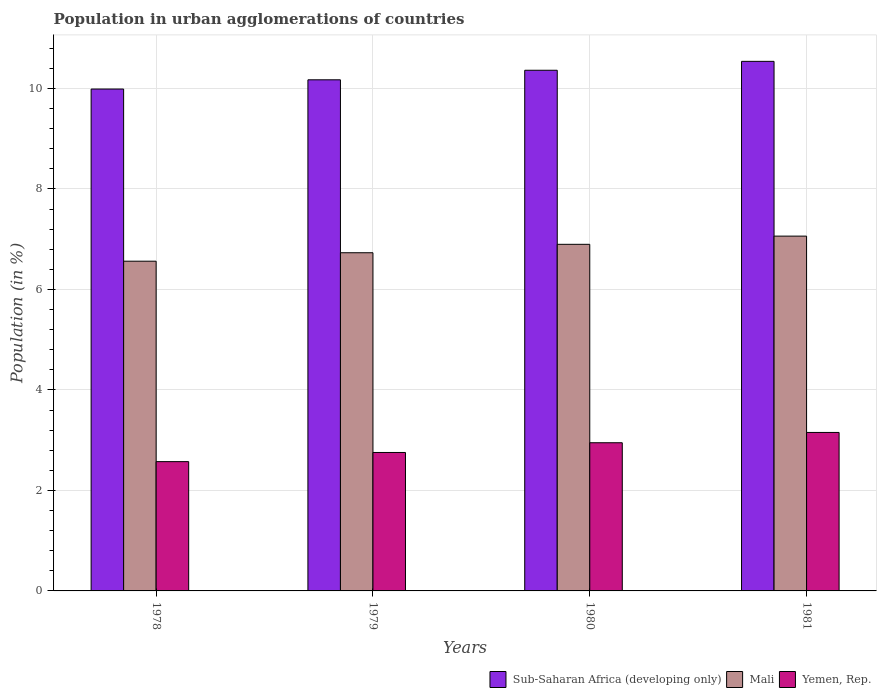How many different coloured bars are there?
Offer a terse response. 3. How many groups of bars are there?
Your response must be concise. 4. Are the number of bars per tick equal to the number of legend labels?
Provide a succinct answer. Yes. Are the number of bars on each tick of the X-axis equal?
Offer a terse response. Yes. How many bars are there on the 1st tick from the left?
Your answer should be very brief. 3. What is the label of the 3rd group of bars from the left?
Offer a very short reply. 1980. What is the percentage of population in urban agglomerations in Mali in 1981?
Keep it short and to the point. 7.06. Across all years, what is the maximum percentage of population in urban agglomerations in Yemen, Rep.?
Offer a terse response. 3.15. Across all years, what is the minimum percentage of population in urban agglomerations in Sub-Saharan Africa (developing only)?
Give a very brief answer. 9.99. In which year was the percentage of population in urban agglomerations in Yemen, Rep. maximum?
Ensure brevity in your answer.  1981. In which year was the percentage of population in urban agglomerations in Yemen, Rep. minimum?
Your response must be concise. 1978. What is the total percentage of population in urban agglomerations in Sub-Saharan Africa (developing only) in the graph?
Your answer should be compact. 41.06. What is the difference between the percentage of population in urban agglomerations in Mali in 1978 and that in 1981?
Ensure brevity in your answer.  -0.5. What is the difference between the percentage of population in urban agglomerations in Sub-Saharan Africa (developing only) in 1981 and the percentage of population in urban agglomerations in Mali in 1978?
Make the answer very short. 3.98. What is the average percentage of population in urban agglomerations in Mali per year?
Your answer should be very brief. 6.81. In the year 1979, what is the difference between the percentage of population in urban agglomerations in Yemen, Rep. and percentage of population in urban agglomerations in Sub-Saharan Africa (developing only)?
Make the answer very short. -7.42. What is the ratio of the percentage of population in urban agglomerations in Sub-Saharan Africa (developing only) in 1980 to that in 1981?
Offer a terse response. 0.98. Is the difference between the percentage of population in urban agglomerations in Yemen, Rep. in 1979 and 1980 greater than the difference between the percentage of population in urban agglomerations in Sub-Saharan Africa (developing only) in 1979 and 1980?
Your answer should be very brief. No. What is the difference between the highest and the second highest percentage of population in urban agglomerations in Sub-Saharan Africa (developing only)?
Offer a very short reply. 0.18. What is the difference between the highest and the lowest percentage of population in urban agglomerations in Sub-Saharan Africa (developing only)?
Your response must be concise. 0.55. What does the 2nd bar from the left in 1981 represents?
Your answer should be compact. Mali. What does the 3rd bar from the right in 1979 represents?
Offer a very short reply. Sub-Saharan Africa (developing only). Is it the case that in every year, the sum of the percentage of population in urban agglomerations in Mali and percentage of population in urban agglomerations in Sub-Saharan Africa (developing only) is greater than the percentage of population in urban agglomerations in Yemen, Rep.?
Your response must be concise. Yes. Are all the bars in the graph horizontal?
Ensure brevity in your answer.  No. Does the graph contain grids?
Provide a succinct answer. Yes. What is the title of the graph?
Provide a succinct answer. Population in urban agglomerations of countries. What is the Population (in %) of Sub-Saharan Africa (developing only) in 1978?
Offer a terse response. 9.99. What is the Population (in %) of Mali in 1978?
Provide a succinct answer. 6.56. What is the Population (in %) of Yemen, Rep. in 1978?
Offer a very short reply. 2.57. What is the Population (in %) in Sub-Saharan Africa (developing only) in 1979?
Your response must be concise. 10.17. What is the Population (in %) of Mali in 1979?
Provide a succinct answer. 6.73. What is the Population (in %) in Yemen, Rep. in 1979?
Make the answer very short. 2.76. What is the Population (in %) in Sub-Saharan Africa (developing only) in 1980?
Ensure brevity in your answer.  10.36. What is the Population (in %) in Mali in 1980?
Provide a succinct answer. 6.9. What is the Population (in %) in Yemen, Rep. in 1980?
Keep it short and to the point. 2.95. What is the Population (in %) of Sub-Saharan Africa (developing only) in 1981?
Your response must be concise. 10.54. What is the Population (in %) in Mali in 1981?
Provide a short and direct response. 7.06. What is the Population (in %) in Yemen, Rep. in 1981?
Provide a short and direct response. 3.15. Across all years, what is the maximum Population (in %) of Sub-Saharan Africa (developing only)?
Provide a short and direct response. 10.54. Across all years, what is the maximum Population (in %) of Mali?
Ensure brevity in your answer.  7.06. Across all years, what is the maximum Population (in %) in Yemen, Rep.?
Your response must be concise. 3.15. Across all years, what is the minimum Population (in %) in Sub-Saharan Africa (developing only)?
Offer a terse response. 9.99. Across all years, what is the minimum Population (in %) in Mali?
Give a very brief answer. 6.56. Across all years, what is the minimum Population (in %) in Yemen, Rep.?
Your answer should be compact. 2.57. What is the total Population (in %) of Sub-Saharan Africa (developing only) in the graph?
Offer a very short reply. 41.06. What is the total Population (in %) in Mali in the graph?
Offer a terse response. 27.25. What is the total Population (in %) of Yemen, Rep. in the graph?
Ensure brevity in your answer.  11.43. What is the difference between the Population (in %) of Sub-Saharan Africa (developing only) in 1978 and that in 1979?
Your answer should be compact. -0.18. What is the difference between the Population (in %) of Mali in 1978 and that in 1979?
Offer a very short reply. -0.17. What is the difference between the Population (in %) in Yemen, Rep. in 1978 and that in 1979?
Offer a very short reply. -0.18. What is the difference between the Population (in %) of Sub-Saharan Africa (developing only) in 1978 and that in 1980?
Ensure brevity in your answer.  -0.37. What is the difference between the Population (in %) of Mali in 1978 and that in 1980?
Your response must be concise. -0.34. What is the difference between the Population (in %) of Yemen, Rep. in 1978 and that in 1980?
Offer a very short reply. -0.38. What is the difference between the Population (in %) in Sub-Saharan Africa (developing only) in 1978 and that in 1981?
Give a very brief answer. -0.55. What is the difference between the Population (in %) in Mali in 1978 and that in 1981?
Offer a very short reply. -0.5. What is the difference between the Population (in %) in Yemen, Rep. in 1978 and that in 1981?
Your answer should be compact. -0.58. What is the difference between the Population (in %) of Sub-Saharan Africa (developing only) in 1979 and that in 1980?
Provide a succinct answer. -0.19. What is the difference between the Population (in %) in Mali in 1979 and that in 1980?
Provide a succinct answer. -0.17. What is the difference between the Population (in %) of Yemen, Rep. in 1979 and that in 1980?
Provide a succinct answer. -0.19. What is the difference between the Population (in %) of Sub-Saharan Africa (developing only) in 1979 and that in 1981?
Make the answer very short. -0.37. What is the difference between the Population (in %) in Mali in 1979 and that in 1981?
Keep it short and to the point. -0.33. What is the difference between the Population (in %) of Yemen, Rep. in 1979 and that in 1981?
Provide a short and direct response. -0.4. What is the difference between the Population (in %) of Sub-Saharan Africa (developing only) in 1980 and that in 1981?
Your answer should be compact. -0.18. What is the difference between the Population (in %) in Mali in 1980 and that in 1981?
Provide a short and direct response. -0.16. What is the difference between the Population (in %) in Yemen, Rep. in 1980 and that in 1981?
Offer a very short reply. -0.2. What is the difference between the Population (in %) in Sub-Saharan Africa (developing only) in 1978 and the Population (in %) in Mali in 1979?
Provide a succinct answer. 3.26. What is the difference between the Population (in %) in Sub-Saharan Africa (developing only) in 1978 and the Population (in %) in Yemen, Rep. in 1979?
Your response must be concise. 7.23. What is the difference between the Population (in %) in Mali in 1978 and the Population (in %) in Yemen, Rep. in 1979?
Your answer should be compact. 3.81. What is the difference between the Population (in %) in Sub-Saharan Africa (developing only) in 1978 and the Population (in %) in Mali in 1980?
Offer a terse response. 3.09. What is the difference between the Population (in %) in Sub-Saharan Africa (developing only) in 1978 and the Population (in %) in Yemen, Rep. in 1980?
Provide a short and direct response. 7.04. What is the difference between the Population (in %) in Mali in 1978 and the Population (in %) in Yemen, Rep. in 1980?
Ensure brevity in your answer.  3.61. What is the difference between the Population (in %) in Sub-Saharan Africa (developing only) in 1978 and the Population (in %) in Mali in 1981?
Provide a short and direct response. 2.93. What is the difference between the Population (in %) of Sub-Saharan Africa (developing only) in 1978 and the Population (in %) of Yemen, Rep. in 1981?
Make the answer very short. 6.83. What is the difference between the Population (in %) in Mali in 1978 and the Population (in %) in Yemen, Rep. in 1981?
Ensure brevity in your answer.  3.41. What is the difference between the Population (in %) in Sub-Saharan Africa (developing only) in 1979 and the Population (in %) in Mali in 1980?
Provide a short and direct response. 3.27. What is the difference between the Population (in %) in Sub-Saharan Africa (developing only) in 1979 and the Population (in %) in Yemen, Rep. in 1980?
Give a very brief answer. 7.22. What is the difference between the Population (in %) in Mali in 1979 and the Population (in %) in Yemen, Rep. in 1980?
Give a very brief answer. 3.78. What is the difference between the Population (in %) in Sub-Saharan Africa (developing only) in 1979 and the Population (in %) in Mali in 1981?
Provide a succinct answer. 3.11. What is the difference between the Population (in %) of Sub-Saharan Africa (developing only) in 1979 and the Population (in %) of Yemen, Rep. in 1981?
Offer a very short reply. 7.02. What is the difference between the Population (in %) of Mali in 1979 and the Population (in %) of Yemen, Rep. in 1981?
Provide a short and direct response. 3.58. What is the difference between the Population (in %) of Sub-Saharan Africa (developing only) in 1980 and the Population (in %) of Mali in 1981?
Offer a terse response. 3.3. What is the difference between the Population (in %) in Sub-Saharan Africa (developing only) in 1980 and the Population (in %) in Yemen, Rep. in 1981?
Provide a succinct answer. 7.21. What is the difference between the Population (in %) in Mali in 1980 and the Population (in %) in Yemen, Rep. in 1981?
Your response must be concise. 3.74. What is the average Population (in %) of Sub-Saharan Africa (developing only) per year?
Offer a terse response. 10.27. What is the average Population (in %) of Mali per year?
Your answer should be very brief. 6.81. What is the average Population (in %) of Yemen, Rep. per year?
Offer a very short reply. 2.86. In the year 1978, what is the difference between the Population (in %) of Sub-Saharan Africa (developing only) and Population (in %) of Mali?
Provide a short and direct response. 3.43. In the year 1978, what is the difference between the Population (in %) in Sub-Saharan Africa (developing only) and Population (in %) in Yemen, Rep.?
Give a very brief answer. 7.42. In the year 1978, what is the difference between the Population (in %) of Mali and Population (in %) of Yemen, Rep.?
Your answer should be compact. 3.99. In the year 1979, what is the difference between the Population (in %) of Sub-Saharan Africa (developing only) and Population (in %) of Mali?
Provide a short and direct response. 3.44. In the year 1979, what is the difference between the Population (in %) of Sub-Saharan Africa (developing only) and Population (in %) of Yemen, Rep.?
Ensure brevity in your answer.  7.42. In the year 1979, what is the difference between the Population (in %) of Mali and Population (in %) of Yemen, Rep.?
Provide a succinct answer. 3.98. In the year 1980, what is the difference between the Population (in %) of Sub-Saharan Africa (developing only) and Population (in %) of Mali?
Provide a short and direct response. 3.46. In the year 1980, what is the difference between the Population (in %) of Sub-Saharan Africa (developing only) and Population (in %) of Yemen, Rep.?
Offer a very short reply. 7.41. In the year 1980, what is the difference between the Population (in %) of Mali and Population (in %) of Yemen, Rep.?
Provide a succinct answer. 3.95. In the year 1981, what is the difference between the Population (in %) in Sub-Saharan Africa (developing only) and Population (in %) in Mali?
Provide a succinct answer. 3.48. In the year 1981, what is the difference between the Population (in %) in Sub-Saharan Africa (developing only) and Population (in %) in Yemen, Rep.?
Your answer should be very brief. 7.39. In the year 1981, what is the difference between the Population (in %) of Mali and Population (in %) of Yemen, Rep.?
Keep it short and to the point. 3.91. What is the ratio of the Population (in %) of Sub-Saharan Africa (developing only) in 1978 to that in 1979?
Give a very brief answer. 0.98. What is the ratio of the Population (in %) of Yemen, Rep. in 1978 to that in 1979?
Keep it short and to the point. 0.93. What is the ratio of the Population (in %) of Sub-Saharan Africa (developing only) in 1978 to that in 1980?
Make the answer very short. 0.96. What is the ratio of the Population (in %) in Mali in 1978 to that in 1980?
Provide a succinct answer. 0.95. What is the ratio of the Population (in %) of Yemen, Rep. in 1978 to that in 1980?
Make the answer very short. 0.87. What is the ratio of the Population (in %) in Sub-Saharan Africa (developing only) in 1978 to that in 1981?
Offer a terse response. 0.95. What is the ratio of the Population (in %) of Mali in 1978 to that in 1981?
Make the answer very short. 0.93. What is the ratio of the Population (in %) in Yemen, Rep. in 1978 to that in 1981?
Offer a terse response. 0.82. What is the ratio of the Population (in %) of Sub-Saharan Africa (developing only) in 1979 to that in 1980?
Offer a terse response. 0.98. What is the ratio of the Population (in %) in Mali in 1979 to that in 1980?
Make the answer very short. 0.98. What is the ratio of the Population (in %) of Yemen, Rep. in 1979 to that in 1980?
Provide a short and direct response. 0.93. What is the ratio of the Population (in %) of Sub-Saharan Africa (developing only) in 1979 to that in 1981?
Make the answer very short. 0.97. What is the ratio of the Population (in %) of Mali in 1979 to that in 1981?
Provide a short and direct response. 0.95. What is the ratio of the Population (in %) of Yemen, Rep. in 1979 to that in 1981?
Offer a very short reply. 0.87. What is the ratio of the Population (in %) in Sub-Saharan Africa (developing only) in 1980 to that in 1981?
Keep it short and to the point. 0.98. What is the ratio of the Population (in %) in Mali in 1980 to that in 1981?
Your response must be concise. 0.98. What is the ratio of the Population (in %) in Yemen, Rep. in 1980 to that in 1981?
Keep it short and to the point. 0.94. What is the difference between the highest and the second highest Population (in %) in Sub-Saharan Africa (developing only)?
Make the answer very short. 0.18. What is the difference between the highest and the second highest Population (in %) in Mali?
Offer a very short reply. 0.16. What is the difference between the highest and the second highest Population (in %) in Yemen, Rep.?
Offer a terse response. 0.2. What is the difference between the highest and the lowest Population (in %) of Sub-Saharan Africa (developing only)?
Your answer should be very brief. 0.55. What is the difference between the highest and the lowest Population (in %) of Mali?
Provide a succinct answer. 0.5. What is the difference between the highest and the lowest Population (in %) in Yemen, Rep.?
Make the answer very short. 0.58. 